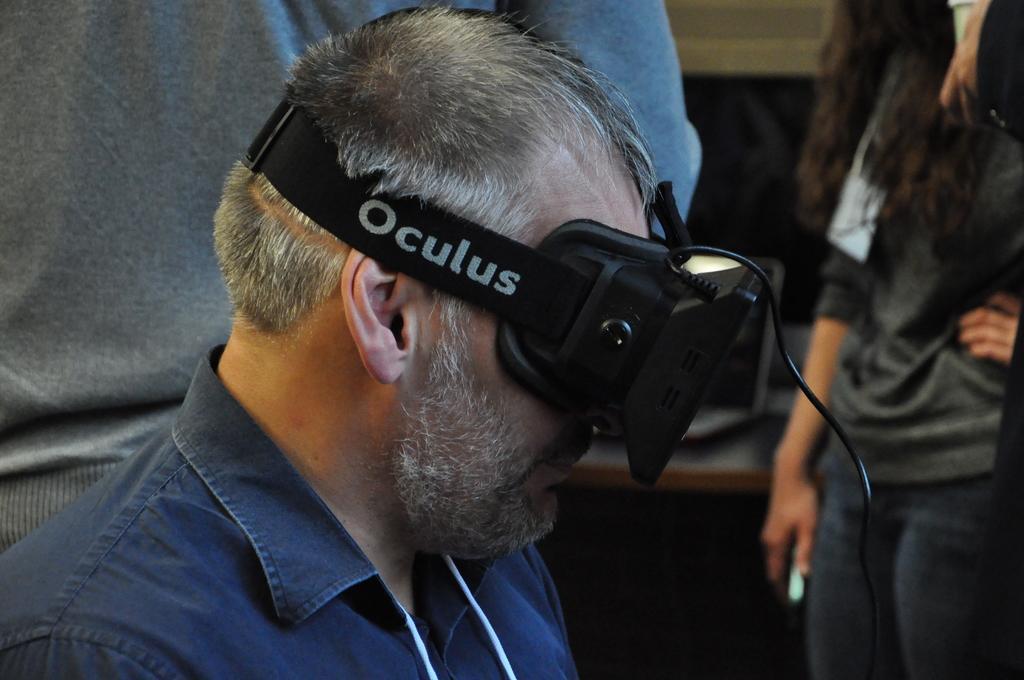How would you summarize this image in a sentence or two? In the center of the image, we can see a person wearing oculus and in the background, there are some other people standing and we can see a table and there is a wall. 